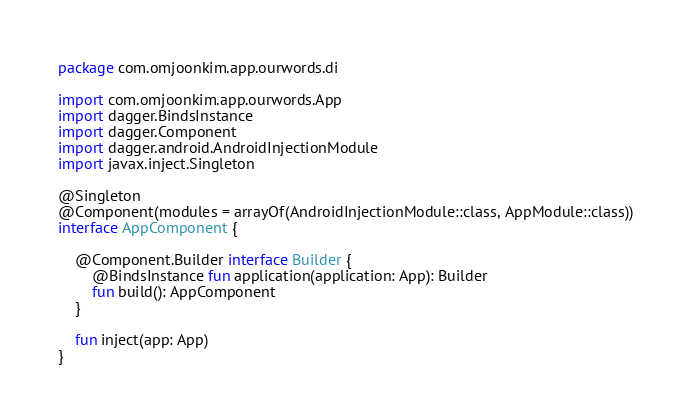<code> <loc_0><loc_0><loc_500><loc_500><_Kotlin_>package com.omjoonkim.app.ourwords.di

import com.omjoonkim.app.ourwords.App
import dagger.BindsInstance
import dagger.Component
import dagger.android.AndroidInjectionModule
import javax.inject.Singleton

@Singleton
@Component(modules = arrayOf(AndroidInjectionModule::class, AppModule::class))
interface AppComponent {

    @Component.Builder interface Builder {
        @BindsInstance fun application(application: App): Builder
        fun build(): AppComponent
    }

    fun inject(app: App)
}</code> 